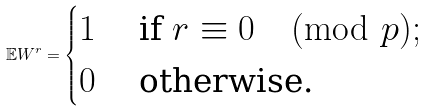<formula> <loc_0><loc_0><loc_500><loc_500>\mathbb { E } W ^ { r } = \begin{cases} 1 & \text { if } r \equiv 0 \pmod { p } ; \\ 0 & \text { otherwise.} \end{cases}</formula> 